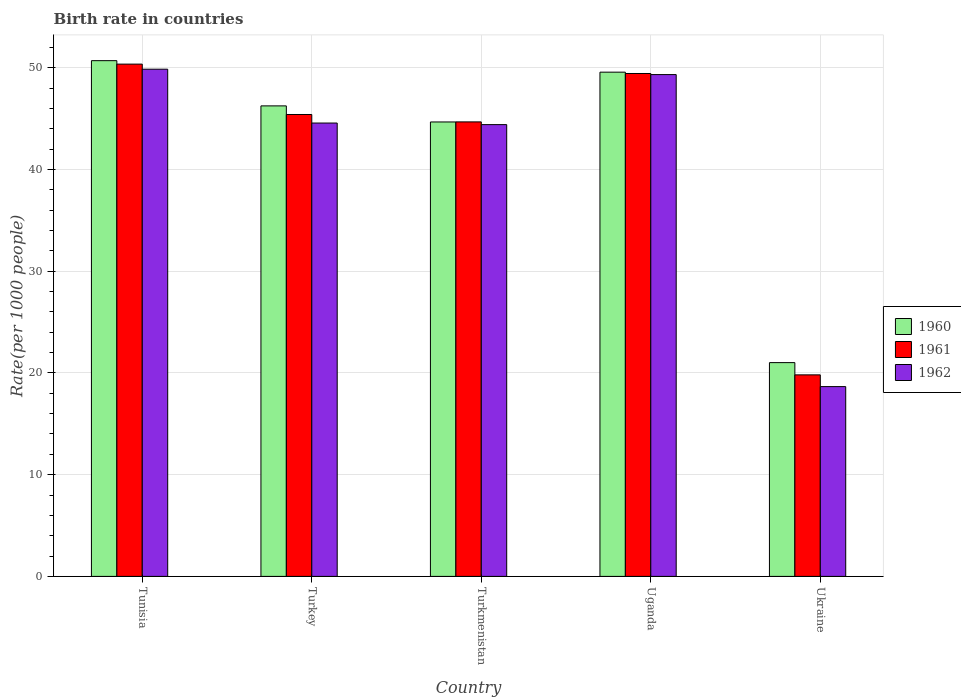How many groups of bars are there?
Your answer should be compact. 5. Are the number of bars per tick equal to the number of legend labels?
Your response must be concise. Yes. How many bars are there on the 5th tick from the right?
Offer a very short reply. 3. What is the label of the 4th group of bars from the left?
Your response must be concise. Uganda. In how many cases, is the number of bars for a given country not equal to the number of legend labels?
Your response must be concise. 0. What is the birth rate in 1962 in Turkey?
Your response must be concise. 44.56. Across all countries, what is the maximum birth rate in 1962?
Offer a terse response. 49.85. Across all countries, what is the minimum birth rate in 1960?
Your response must be concise. 21.01. In which country was the birth rate in 1961 maximum?
Give a very brief answer. Tunisia. In which country was the birth rate in 1962 minimum?
Your answer should be very brief. Ukraine. What is the total birth rate in 1960 in the graph?
Offer a terse response. 212.16. What is the difference between the birth rate in 1960 in Tunisia and that in Turkmenistan?
Your response must be concise. 6.02. What is the difference between the birth rate in 1960 in Ukraine and the birth rate in 1961 in Tunisia?
Offer a very short reply. -29.34. What is the average birth rate in 1960 per country?
Ensure brevity in your answer.  42.43. What is the difference between the birth rate of/in 1962 and birth rate of/in 1960 in Uganda?
Offer a very short reply. -0.24. In how many countries, is the birth rate in 1962 greater than 4?
Your answer should be very brief. 5. What is the ratio of the birth rate in 1960 in Turkey to that in Ukraine?
Ensure brevity in your answer.  2.2. Is the difference between the birth rate in 1962 in Turkmenistan and Ukraine greater than the difference between the birth rate in 1960 in Turkmenistan and Ukraine?
Make the answer very short. Yes. What is the difference between the highest and the second highest birth rate in 1960?
Offer a terse response. -1.13. What is the difference between the highest and the lowest birth rate in 1962?
Your answer should be very brief. 31.19. What does the 2nd bar from the right in Turkmenistan represents?
Provide a short and direct response. 1961. How many bars are there?
Provide a succinct answer. 15. Are all the bars in the graph horizontal?
Keep it short and to the point. No. How many countries are there in the graph?
Your answer should be very brief. 5. What is the difference between two consecutive major ticks on the Y-axis?
Offer a very short reply. 10. Are the values on the major ticks of Y-axis written in scientific E-notation?
Provide a succinct answer. No. Does the graph contain grids?
Keep it short and to the point. Yes. Where does the legend appear in the graph?
Your answer should be compact. Center right. How many legend labels are there?
Make the answer very short. 3. What is the title of the graph?
Your response must be concise. Birth rate in countries. What is the label or title of the Y-axis?
Your response must be concise. Rate(per 1000 people). What is the Rate(per 1000 people) of 1960 in Tunisia?
Your answer should be very brief. 50.69. What is the Rate(per 1000 people) in 1961 in Tunisia?
Your answer should be very brief. 50.35. What is the Rate(per 1000 people) of 1962 in Tunisia?
Make the answer very short. 49.85. What is the Rate(per 1000 people) in 1960 in Turkey?
Your answer should be very brief. 46.24. What is the Rate(per 1000 people) of 1961 in Turkey?
Keep it short and to the point. 45.4. What is the Rate(per 1000 people) of 1962 in Turkey?
Give a very brief answer. 44.56. What is the Rate(per 1000 people) of 1960 in Turkmenistan?
Your answer should be compact. 44.66. What is the Rate(per 1000 people) of 1961 in Turkmenistan?
Ensure brevity in your answer.  44.67. What is the Rate(per 1000 people) of 1962 in Turkmenistan?
Provide a short and direct response. 44.4. What is the Rate(per 1000 people) of 1960 in Uganda?
Keep it short and to the point. 49.56. What is the Rate(per 1000 people) of 1961 in Uganda?
Make the answer very short. 49.43. What is the Rate(per 1000 people) of 1962 in Uganda?
Offer a terse response. 49.32. What is the Rate(per 1000 people) of 1960 in Ukraine?
Make the answer very short. 21.01. What is the Rate(per 1000 people) in 1961 in Ukraine?
Your answer should be compact. 19.81. What is the Rate(per 1000 people) in 1962 in Ukraine?
Your answer should be compact. 18.65. Across all countries, what is the maximum Rate(per 1000 people) in 1960?
Provide a succinct answer. 50.69. Across all countries, what is the maximum Rate(per 1000 people) in 1961?
Make the answer very short. 50.35. Across all countries, what is the maximum Rate(per 1000 people) in 1962?
Make the answer very short. 49.85. Across all countries, what is the minimum Rate(per 1000 people) in 1960?
Keep it short and to the point. 21.01. Across all countries, what is the minimum Rate(per 1000 people) in 1961?
Your answer should be compact. 19.81. Across all countries, what is the minimum Rate(per 1000 people) in 1962?
Give a very brief answer. 18.65. What is the total Rate(per 1000 people) in 1960 in the graph?
Provide a succinct answer. 212.16. What is the total Rate(per 1000 people) in 1961 in the graph?
Offer a terse response. 209.65. What is the total Rate(per 1000 people) in 1962 in the graph?
Your answer should be compact. 206.78. What is the difference between the Rate(per 1000 people) in 1960 in Tunisia and that in Turkey?
Offer a very short reply. 4.45. What is the difference between the Rate(per 1000 people) of 1961 in Tunisia and that in Turkey?
Your answer should be compact. 4.95. What is the difference between the Rate(per 1000 people) in 1962 in Tunisia and that in Turkey?
Offer a very short reply. 5.29. What is the difference between the Rate(per 1000 people) of 1960 in Tunisia and that in Turkmenistan?
Your response must be concise. 6.02. What is the difference between the Rate(per 1000 people) of 1961 in Tunisia and that in Turkmenistan?
Your answer should be very brief. 5.68. What is the difference between the Rate(per 1000 people) of 1962 in Tunisia and that in Turkmenistan?
Your answer should be very brief. 5.45. What is the difference between the Rate(per 1000 people) in 1960 in Tunisia and that in Uganda?
Provide a short and direct response. 1.13. What is the difference between the Rate(per 1000 people) in 1961 in Tunisia and that in Uganda?
Ensure brevity in your answer.  0.92. What is the difference between the Rate(per 1000 people) in 1962 in Tunisia and that in Uganda?
Keep it short and to the point. 0.53. What is the difference between the Rate(per 1000 people) of 1960 in Tunisia and that in Ukraine?
Ensure brevity in your answer.  29.68. What is the difference between the Rate(per 1000 people) of 1961 in Tunisia and that in Ukraine?
Your answer should be very brief. 30.54. What is the difference between the Rate(per 1000 people) of 1962 in Tunisia and that in Ukraine?
Offer a terse response. 31.2. What is the difference between the Rate(per 1000 people) in 1960 in Turkey and that in Turkmenistan?
Provide a succinct answer. 1.58. What is the difference between the Rate(per 1000 people) of 1961 in Turkey and that in Turkmenistan?
Give a very brief answer. 0.73. What is the difference between the Rate(per 1000 people) in 1962 in Turkey and that in Turkmenistan?
Your answer should be very brief. 0.15. What is the difference between the Rate(per 1000 people) in 1960 in Turkey and that in Uganda?
Your answer should be compact. -3.31. What is the difference between the Rate(per 1000 people) in 1961 in Turkey and that in Uganda?
Your answer should be compact. -4.03. What is the difference between the Rate(per 1000 people) of 1962 in Turkey and that in Uganda?
Your answer should be compact. -4.76. What is the difference between the Rate(per 1000 people) in 1960 in Turkey and that in Ukraine?
Give a very brief answer. 25.23. What is the difference between the Rate(per 1000 people) of 1961 in Turkey and that in Ukraine?
Keep it short and to the point. 25.59. What is the difference between the Rate(per 1000 people) of 1962 in Turkey and that in Ukraine?
Your response must be concise. 25.9. What is the difference between the Rate(per 1000 people) in 1960 in Turkmenistan and that in Uganda?
Your answer should be very brief. -4.89. What is the difference between the Rate(per 1000 people) in 1961 in Turkmenistan and that in Uganda?
Your answer should be compact. -4.76. What is the difference between the Rate(per 1000 people) in 1962 in Turkmenistan and that in Uganda?
Offer a terse response. -4.92. What is the difference between the Rate(per 1000 people) in 1960 in Turkmenistan and that in Ukraine?
Provide a short and direct response. 23.65. What is the difference between the Rate(per 1000 people) of 1961 in Turkmenistan and that in Ukraine?
Make the answer very short. 24.86. What is the difference between the Rate(per 1000 people) of 1962 in Turkmenistan and that in Ukraine?
Keep it short and to the point. 25.75. What is the difference between the Rate(per 1000 people) in 1960 in Uganda and that in Ukraine?
Your response must be concise. 28.55. What is the difference between the Rate(per 1000 people) of 1961 in Uganda and that in Ukraine?
Your response must be concise. 29.62. What is the difference between the Rate(per 1000 people) in 1962 in Uganda and that in Ukraine?
Ensure brevity in your answer.  30.66. What is the difference between the Rate(per 1000 people) of 1960 in Tunisia and the Rate(per 1000 people) of 1961 in Turkey?
Provide a short and direct response. 5.29. What is the difference between the Rate(per 1000 people) of 1960 in Tunisia and the Rate(per 1000 people) of 1962 in Turkey?
Offer a very short reply. 6.13. What is the difference between the Rate(per 1000 people) in 1961 in Tunisia and the Rate(per 1000 people) in 1962 in Turkey?
Your response must be concise. 5.79. What is the difference between the Rate(per 1000 people) in 1960 in Tunisia and the Rate(per 1000 people) in 1961 in Turkmenistan?
Offer a terse response. 6.02. What is the difference between the Rate(per 1000 people) in 1960 in Tunisia and the Rate(per 1000 people) in 1962 in Turkmenistan?
Keep it short and to the point. 6.29. What is the difference between the Rate(per 1000 people) of 1961 in Tunisia and the Rate(per 1000 people) of 1962 in Turkmenistan?
Provide a succinct answer. 5.95. What is the difference between the Rate(per 1000 people) of 1960 in Tunisia and the Rate(per 1000 people) of 1961 in Uganda?
Provide a short and direct response. 1.26. What is the difference between the Rate(per 1000 people) in 1960 in Tunisia and the Rate(per 1000 people) in 1962 in Uganda?
Offer a very short reply. 1.37. What is the difference between the Rate(per 1000 people) in 1961 in Tunisia and the Rate(per 1000 people) in 1962 in Uganda?
Offer a very short reply. 1.03. What is the difference between the Rate(per 1000 people) of 1960 in Tunisia and the Rate(per 1000 people) of 1961 in Ukraine?
Your response must be concise. 30.88. What is the difference between the Rate(per 1000 people) of 1960 in Tunisia and the Rate(per 1000 people) of 1962 in Ukraine?
Provide a succinct answer. 32.03. What is the difference between the Rate(per 1000 people) in 1961 in Tunisia and the Rate(per 1000 people) in 1962 in Ukraine?
Provide a succinct answer. 31.69. What is the difference between the Rate(per 1000 people) in 1960 in Turkey and the Rate(per 1000 people) in 1961 in Turkmenistan?
Your response must be concise. 1.57. What is the difference between the Rate(per 1000 people) in 1960 in Turkey and the Rate(per 1000 people) in 1962 in Turkmenistan?
Your answer should be very brief. 1.84. What is the difference between the Rate(per 1000 people) of 1960 in Turkey and the Rate(per 1000 people) of 1961 in Uganda?
Offer a terse response. -3.18. What is the difference between the Rate(per 1000 people) in 1960 in Turkey and the Rate(per 1000 people) in 1962 in Uganda?
Provide a short and direct response. -3.08. What is the difference between the Rate(per 1000 people) of 1961 in Turkey and the Rate(per 1000 people) of 1962 in Uganda?
Keep it short and to the point. -3.92. What is the difference between the Rate(per 1000 people) in 1960 in Turkey and the Rate(per 1000 people) in 1961 in Ukraine?
Your answer should be very brief. 26.43. What is the difference between the Rate(per 1000 people) in 1960 in Turkey and the Rate(per 1000 people) in 1962 in Ukraine?
Your response must be concise. 27.59. What is the difference between the Rate(per 1000 people) of 1961 in Turkey and the Rate(per 1000 people) of 1962 in Ukraine?
Ensure brevity in your answer.  26.74. What is the difference between the Rate(per 1000 people) of 1960 in Turkmenistan and the Rate(per 1000 people) of 1961 in Uganda?
Make the answer very short. -4.76. What is the difference between the Rate(per 1000 people) of 1960 in Turkmenistan and the Rate(per 1000 people) of 1962 in Uganda?
Provide a short and direct response. -4.66. What is the difference between the Rate(per 1000 people) in 1961 in Turkmenistan and the Rate(per 1000 people) in 1962 in Uganda?
Your answer should be compact. -4.65. What is the difference between the Rate(per 1000 people) of 1960 in Turkmenistan and the Rate(per 1000 people) of 1961 in Ukraine?
Offer a very short reply. 24.86. What is the difference between the Rate(per 1000 people) in 1960 in Turkmenistan and the Rate(per 1000 people) in 1962 in Ukraine?
Give a very brief answer. 26.01. What is the difference between the Rate(per 1000 people) of 1961 in Turkmenistan and the Rate(per 1000 people) of 1962 in Ukraine?
Give a very brief answer. 26.02. What is the difference between the Rate(per 1000 people) in 1960 in Uganda and the Rate(per 1000 people) in 1961 in Ukraine?
Your answer should be very brief. 29.75. What is the difference between the Rate(per 1000 people) of 1960 in Uganda and the Rate(per 1000 people) of 1962 in Ukraine?
Offer a very short reply. 30.9. What is the difference between the Rate(per 1000 people) of 1961 in Uganda and the Rate(per 1000 people) of 1962 in Ukraine?
Your answer should be compact. 30.77. What is the average Rate(per 1000 people) in 1960 per country?
Ensure brevity in your answer.  42.43. What is the average Rate(per 1000 people) of 1961 per country?
Provide a short and direct response. 41.93. What is the average Rate(per 1000 people) of 1962 per country?
Give a very brief answer. 41.36. What is the difference between the Rate(per 1000 people) in 1960 and Rate(per 1000 people) in 1961 in Tunisia?
Your response must be concise. 0.34. What is the difference between the Rate(per 1000 people) in 1960 and Rate(per 1000 people) in 1962 in Tunisia?
Make the answer very short. 0.84. What is the difference between the Rate(per 1000 people) of 1961 and Rate(per 1000 people) of 1962 in Tunisia?
Provide a short and direct response. 0.5. What is the difference between the Rate(per 1000 people) of 1960 and Rate(per 1000 people) of 1961 in Turkey?
Ensure brevity in your answer.  0.84. What is the difference between the Rate(per 1000 people) of 1960 and Rate(per 1000 people) of 1962 in Turkey?
Offer a very short reply. 1.69. What is the difference between the Rate(per 1000 people) of 1961 and Rate(per 1000 people) of 1962 in Turkey?
Make the answer very short. 0.84. What is the difference between the Rate(per 1000 people) in 1960 and Rate(per 1000 people) in 1961 in Turkmenistan?
Offer a terse response. -0.01. What is the difference between the Rate(per 1000 people) in 1960 and Rate(per 1000 people) in 1962 in Turkmenistan?
Your answer should be very brief. 0.26. What is the difference between the Rate(per 1000 people) in 1961 and Rate(per 1000 people) in 1962 in Turkmenistan?
Offer a terse response. 0.27. What is the difference between the Rate(per 1000 people) of 1960 and Rate(per 1000 people) of 1961 in Uganda?
Your response must be concise. 0.13. What is the difference between the Rate(per 1000 people) of 1960 and Rate(per 1000 people) of 1962 in Uganda?
Ensure brevity in your answer.  0.24. What is the difference between the Rate(per 1000 people) in 1961 and Rate(per 1000 people) in 1962 in Uganda?
Provide a succinct answer. 0.11. What is the difference between the Rate(per 1000 people) of 1960 and Rate(per 1000 people) of 1961 in Ukraine?
Offer a terse response. 1.2. What is the difference between the Rate(per 1000 people) of 1960 and Rate(per 1000 people) of 1962 in Ukraine?
Offer a terse response. 2.36. What is the difference between the Rate(per 1000 people) in 1961 and Rate(per 1000 people) in 1962 in Ukraine?
Provide a succinct answer. 1.15. What is the ratio of the Rate(per 1000 people) of 1960 in Tunisia to that in Turkey?
Provide a succinct answer. 1.1. What is the ratio of the Rate(per 1000 people) of 1961 in Tunisia to that in Turkey?
Your answer should be very brief. 1.11. What is the ratio of the Rate(per 1000 people) of 1962 in Tunisia to that in Turkey?
Provide a succinct answer. 1.12. What is the ratio of the Rate(per 1000 people) of 1960 in Tunisia to that in Turkmenistan?
Your response must be concise. 1.13. What is the ratio of the Rate(per 1000 people) of 1961 in Tunisia to that in Turkmenistan?
Provide a short and direct response. 1.13. What is the ratio of the Rate(per 1000 people) in 1962 in Tunisia to that in Turkmenistan?
Keep it short and to the point. 1.12. What is the ratio of the Rate(per 1000 people) of 1960 in Tunisia to that in Uganda?
Provide a short and direct response. 1.02. What is the ratio of the Rate(per 1000 people) of 1961 in Tunisia to that in Uganda?
Offer a terse response. 1.02. What is the ratio of the Rate(per 1000 people) of 1962 in Tunisia to that in Uganda?
Offer a very short reply. 1.01. What is the ratio of the Rate(per 1000 people) in 1960 in Tunisia to that in Ukraine?
Make the answer very short. 2.41. What is the ratio of the Rate(per 1000 people) of 1961 in Tunisia to that in Ukraine?
Your answer should be very brief. 2.54. What is the ratio of the Rate(per 1000 people) of 1962 in Tunisia to that in Ukraine?
Give a very brief answer. 2.67. What is the ratio of the Rate(per 1000 people) in 1960 in Turkey to that in Turkmenistan?
Your answer should be very brief. 1.04. What is the ratio of the Rate(per 1000 people) of 1961 in Turkey to that in Turkmenistan?
Keep it short and to the point. 1.02. What is the ratio of the Rate(per 1000 people) of 1960 in Turkey to that in Uganda?
Offer a very short reply. 0.93. What is the ratio of the Rate(per 1000 people) in 1961 in Turkey to that in Uganda?
Offer a very short reply. 0.92. What is the ratio of the Rate(per 1000 people) in 1962 in Turkey to that in Uganda?
Your answer should be very brief. 0.9. What is the ratio of the Rate(per 1000 people) of 1960 in Turkey to that in Ukraine?
Give a very brief answer. 2.2. What is the ratio of the Rate(per 1000 people) of 1961 in Turkey to that in Ukraine?
Offer a terse response. 2.29. What is the ratio of the Rate(per 1000 people) of 1962 in Turkey to that in Ukraine?
Offer a very short reply. 2.39. What is the ratio of the Rate(per 1000 people) of 1960 in Turkmenistan to that in Uganda?
Keep it short and to the point. 0.9. What is the ratio of the Rate(per 1000 people) of 1961 in Turkmenistan to that in Uganda?
Offer a very short reply. 0.9. What is the ratio of the Rate(per 1000 people) in 1962 in Turkmenistan to that in Uganda?
Your answer should be very brief. 0.9. What is the ratio of the Rate(per 1000 people) in 1960 in Turkmenistan to that in Ukraine?
Ensure brevity in your answer.  2.13. What is the ratio of the Rate(per 1000 people) of 1961 in Turkmenistan to that in Ukraine?
Ensure brevity in your answer.  2.26. What is the ratio of the Rate(per 1000 people) in 1962 in Turkmenistan to that in Ukraine?
Provide a succinct answer. 2.38. What is the ratio of the Rate(per 1000 people) in 1960 in Uganda to that in Ukraine?
Your response must be concise. 2.36. What is the ratio of the Rate(per 1000 people) of 1961 in Uganda to that in Ukraine?
Keep it short and to the point. 2.5. What is the ratio of the Rate(per 1000 people) of 1962 in Uganda to that in Ukraine?
Your response must be concise. 2.64. What is the difference between the highest and the second highest Rate(per 1000 people) of 1960?
Your answer should be compact. 1.13. What is the difference between the highest and the second highest Rate(per 1000 people) in 1961?
Provide a succinct answer. 0.92. What is the difference between the highest and the second highest Rate(per 1000 people) in 1962?
Make the answer very short. 0.53. What is the difference between the highest and the lowest Rate(per 1000 people) in 1960?
Your answer should be compact. 29.68. What is the difference between the highest and the lowest Rate(per 1000 people) of 1961?
Offer a very short reply. 30.54. What is the difference between the highest and the lowest Rate(per 1000 people) in 1962?
Keep it short and to the point. 31.2. 